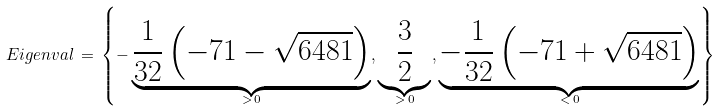Convert formula to latex. <formula><loc_0><loc_0><loc_500><loc_500>E i g e n v a l \, = \, \left \{ - \underbrace { \frac { 1 } { 3 2 } \left ( - 7 1 - \sqrt { 6 4 8 1 } \right ) } _ { > \, 0 } , \underbrace { \frac { 3 } { 2 } } _ { > \, 0 } , \underbrace { - \frac { 1 } { 3 2 } \left ( - 7 1 + \sqrt { 6 4 8 1 } \right ) } _ { < \, 0 } \right \}</formula> 